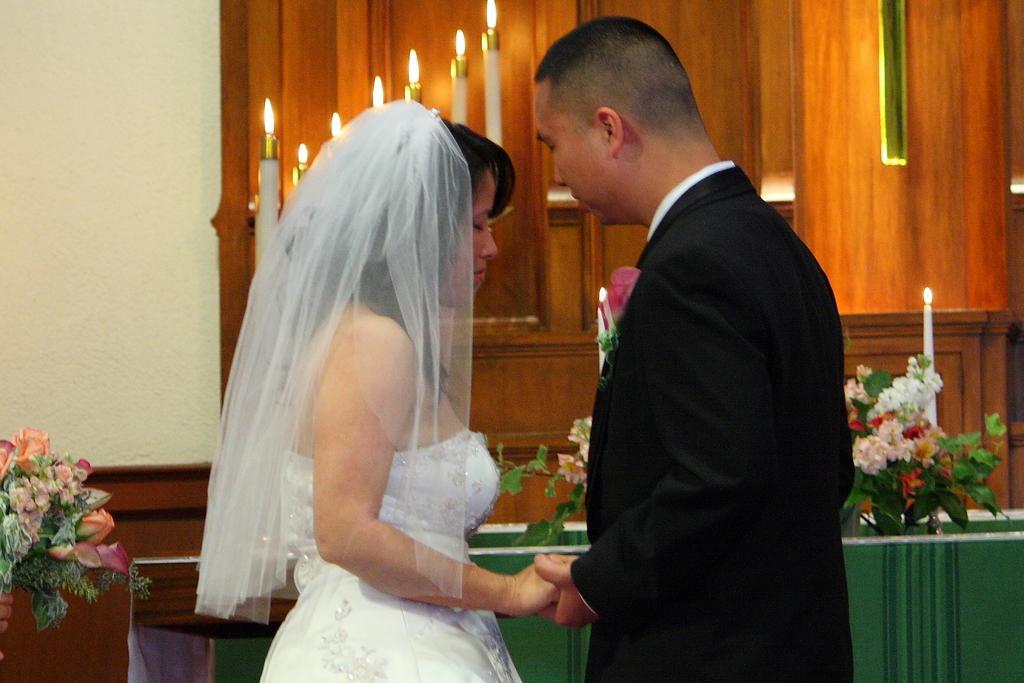Could you give a brief overview of what you see in this image? In this picture we can see there are two people standing on the path and behind the people there are flower vase and candles with flames. Behind the flower vases there is a wall and a wooden object. 